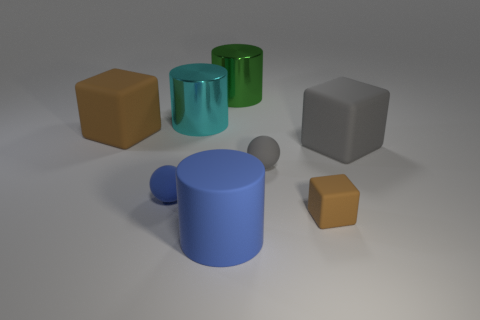Add 1 tiny brown things. How many objects exist? 9 Subtract all balls. How many objects are left? 6 Subtract 0 yellow spheres. How many objects are left? 8 Subtract all blue rubber cubes. Subtract all large blue rubber things. How many objects are left? 7 Add 3 big green things. How many big green things are left? 4 Add 7 large blue things. How many large blue things exist? 8 